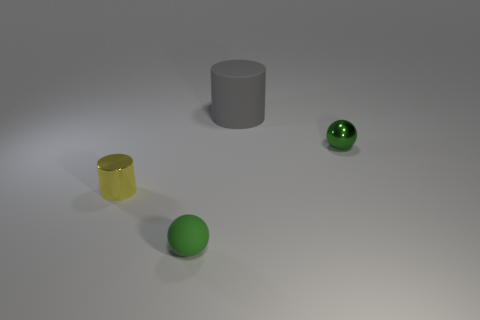There is a tiny green thing that is to the left of the gray rubber object; does it have the same shape as the green metallic object?
Offer a terse response. Yes. What is the material of the tiny yellow cylinder?
Your response must be concise. Metal. What is the shape of the small green thing to the right of the sphere that is on the left side of the tiny green object that is behind the small yellow thing?
Provide a succinct answer. Sphere. Does the big rubber cylinder have the same color as the rubber object that is left of the rubber cylinder?
Provide a succinct answer. No. How many gray things are there?
Provide a short and direct response. 1. What number of things are either cylinders or green matte balls?
Your answer should be very brief. 3. What is the size of the other ball that is the same color as the tiny metallic sphere?
Offer a terse response. Small. Are there any tiny matte objects on the left side of the gray matte cylinder?
Give a very brief answer. Yes. Are there more green metallic objects that are on the left side of the small matte object than large gray things that are behind the large gray rubber cylinder?
Keep it short and to the point. No. The other thing that is the same shape as the big gray rubber object is what size?
Ensure brevity in your answer.  Small. 